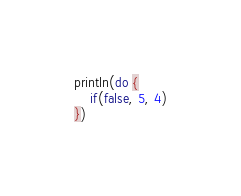<code> <loc_0><loc_0><loc_500><loc_500><_SQL_>println(do {
    if(false, 5, 4)
})</code> 